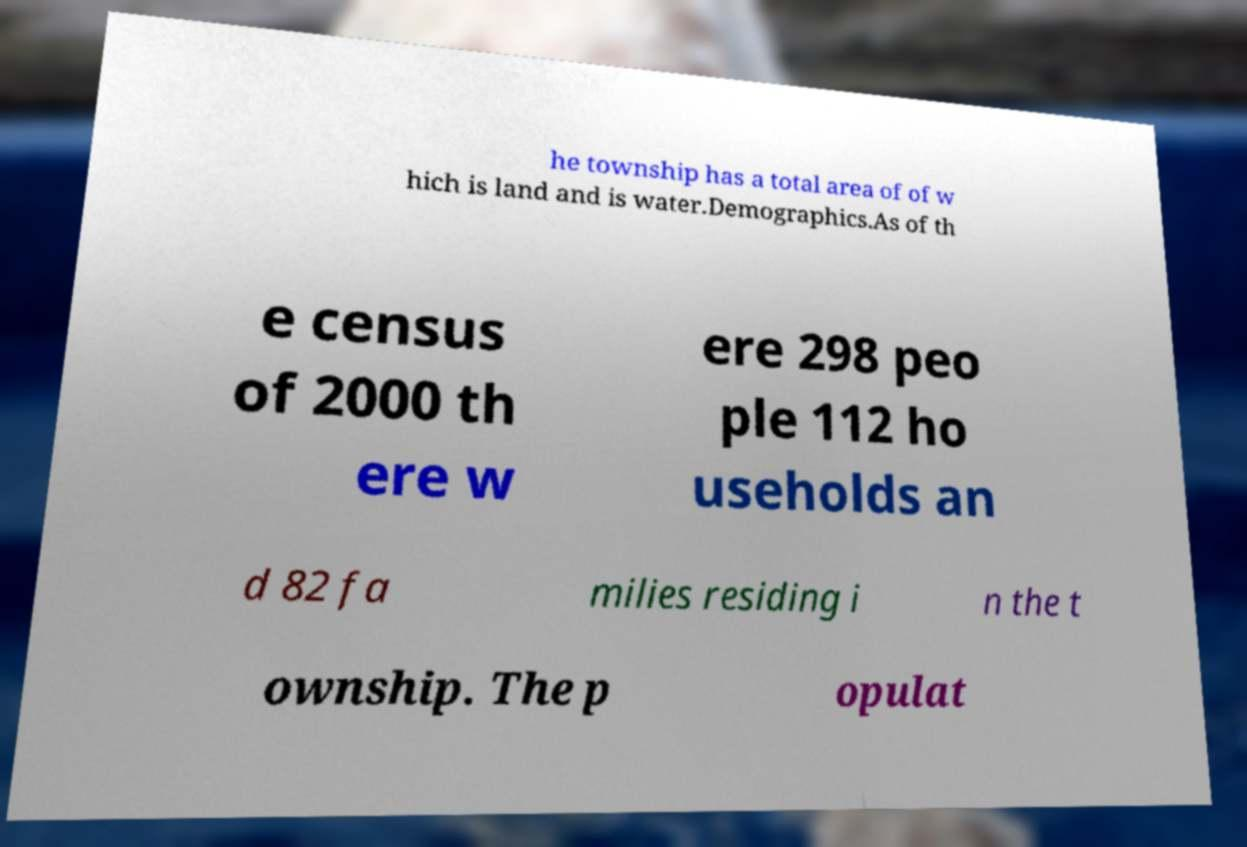Could you extract and type out the text from this image? he township has a total area of of w hich is land and is water.Demographics.As of th e census of 2000 th ere w ere 298 peo ple 112 ho useholds an d 82 fa milies residing i n the t ownship. The p opulat 